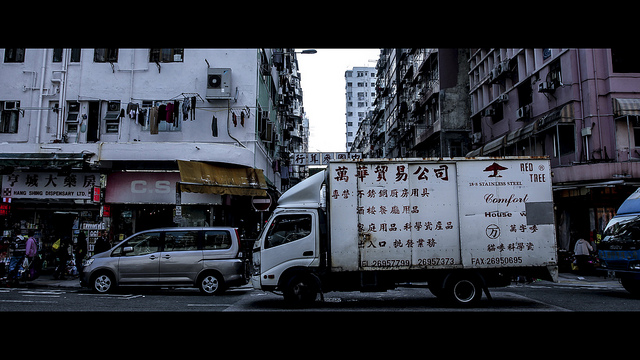What might be some reasons the businesses in this area use delivery trucks? Delivery trucks are often used in urban areas for various reasons: they facilitate the transport of goods in bulk from suppliers to brick-and-mortar stores, support local businesses in distributing their products, and ensure a steady supply chain in densely populated regions. Due to limited access and parking, smaller, more maneuverable trucks like the one pictured are typically favored for these tasks. 